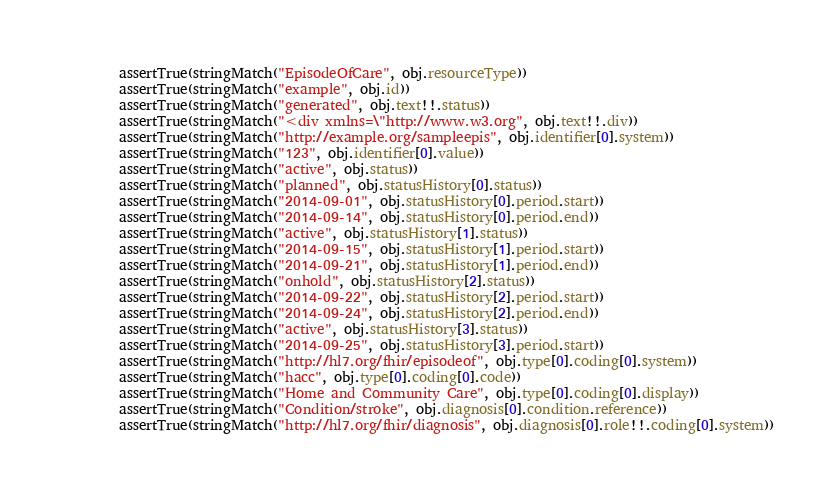<code> <loc_0><loc_0><loc_500><loc_500><_Kotlin_>        assertTrue(stringMatch("EpisodeOfCare", obj.resourceType))
        assertTrue(stringMatch("example", obj.id))
        assertTrue(stringMatch("generated", obj.text!!.status))
        assertTrue(stringMatch("<div xmlns=\"http://www.w3.org", obj.text!!.div))
        assertTrue(stringMatch("http://example.org/sampleepis", obj.identifier[0].system))
        assertTrue(stringMatch("123", obj.identifier[0].value))
        assertTrue(stringMatch("active", obj.status))
        assertTrue(stringMatch("planned", obj.statusHistory[0].status))
        assertTrue(stringMatch("2014-09-01", obj.statusHistory[0].period.start))
        assertTrue(stringMatch("2014-09-14", obj.statusHistory[0].period.end))
        assertTrue(stringMatch("active", obj.statusHistory[1].status))
        assertTrue(stringMatch("2014-09-15", obj.statusHistory[1].period.start))
        assertTrue(stringMatch("2014-09-21", obj.statusHistory[1].period.end))
        assertTrue(stringMatch("onhold", obj.statusHistory[2].status))
        assertTrue(stringMatch("2014-09-22", obj.statusHistory[2].period.start))
        assertTrue(stringMatch("2014-09-24", obj.statusHistory[2].period.end))
        assertTrue(stringMatch("active", obj.statusHistory[3].status))
        assertTrue(stringMatch("2014-09-25", obj.statusHistory[3].period.start))
        assertTrue(stringMatch("http://hl7.org/fhir/episodeof", obj.type[0].coding[0].system))
        assertTrue(stringMatch("hacc", obj.type[0].coding[0].code))
        assertTrue(stringMatch("Home and Community Care", obj.type[0].coding[0].display))
        assertTrue(stringMatch("Condition/stroke", obj.diagnosis[0].condition.reference))
        assertTrue(stringMatch("http://hl7.org/fhir/diagnosis", obj.diagnosis[0].role!!.coding[0].system))</code> 